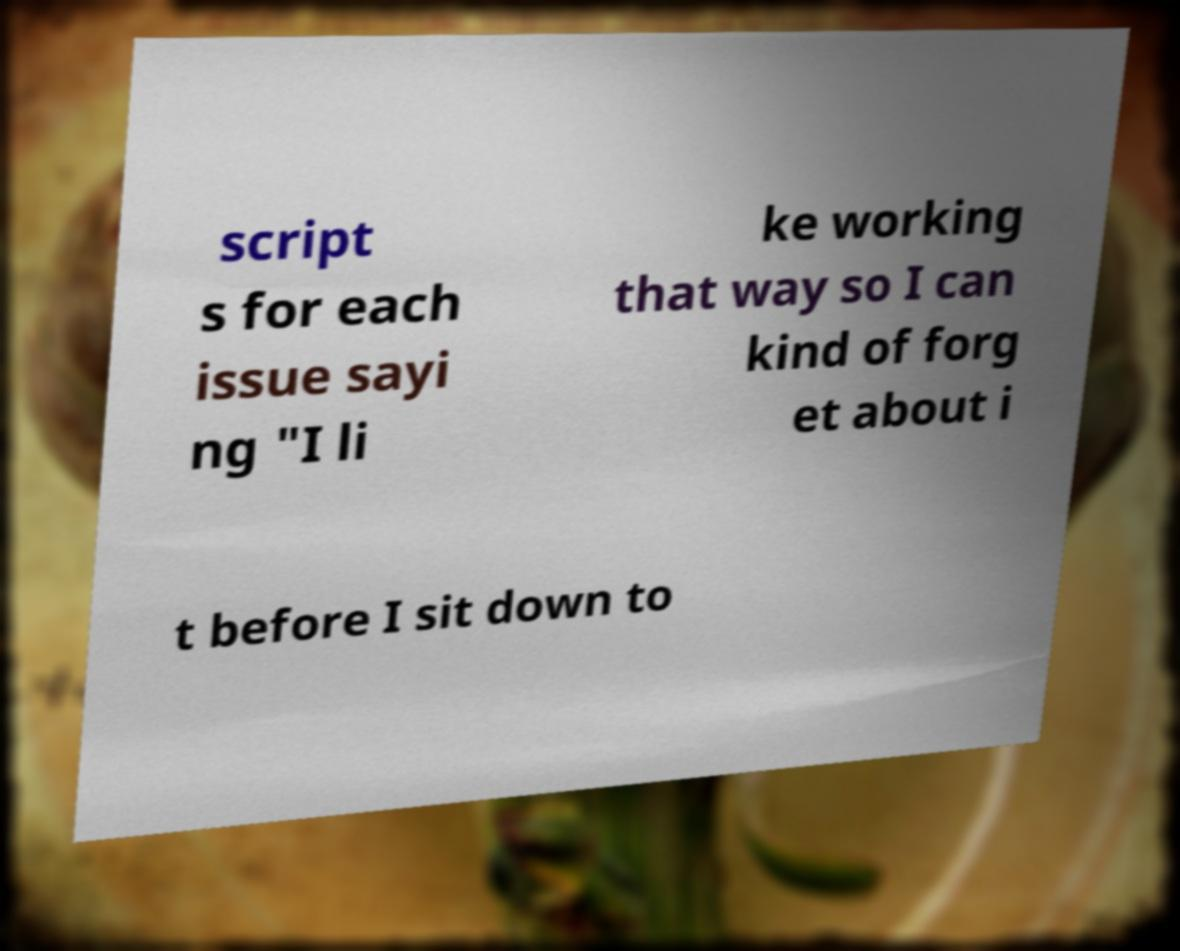Could you assist in decoding the text presented in this image and type it out clearly? script s for each issue sayi ng "I li ke working that way so I can kind of forg et about i t before I sit down to 